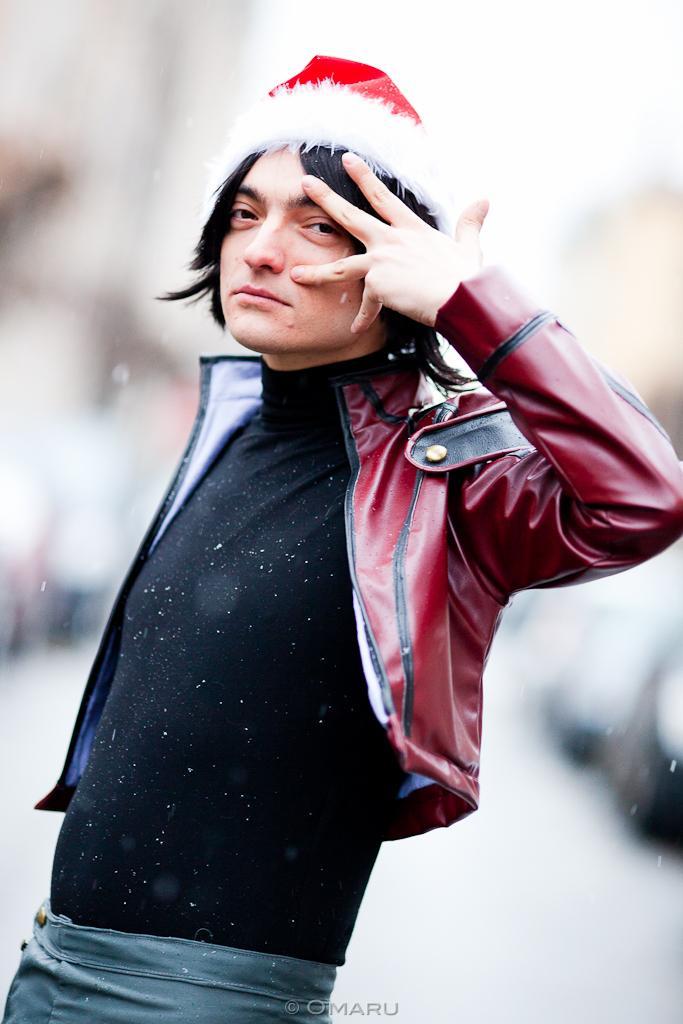In one or two sentences, can you explain what this image depicts? In this picture there is a man who is standing in the center of the image and the background area of the image is blur. 